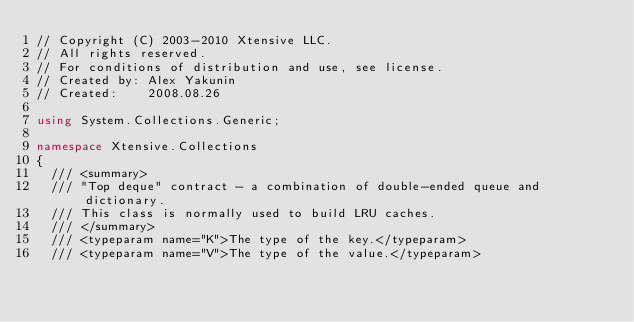<code> <loc_0><loc_0><loc_500><loc_500><_C#_>// Copyright (C) 2003-2010 Xtensive LLC.
// All rights reserved.
// For conditions of distribution and use, see license.
// Created by: Alex Yakunin
// Created:    2008.08.26

using System.Collections.Generic;

namespace Xtensive.Collections
{
  /// <summary>
  /// "Top deque" contract - a combination of double-ended queue and dictionary.
  /// This class is normally used to build LRU caches.
  /// </summary>
  /// <typeparam name="K">The type of the key.</typeparam>
  /// <typeparam name="V">The type of the value.</typeparam></code> 